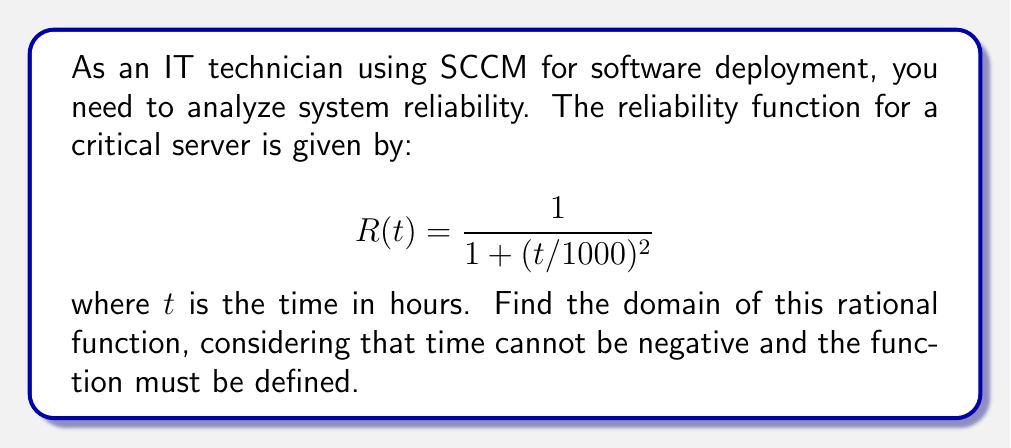Provide a solution to this math problem. To find the domain of the rational function, we need to follow these steps:

1) First, recall that for any rational function $\frac{p(x)}{q(x)}$, the domain includes all real numbers except those that make the denominator equal to zero.

2) In this case, our function is:
   $$R(t) = \frac{1}{1 + (t/1000)^2}$$

3) The denominator is $1 + (t/1000)^2$. We need to find values of $t$ that make this equal to zero:
   $$1 + (t/1000)^2 = 0$$

4) Solving this equation:
   $$(t/1000)^2 = -1$$

5) However, the square of a real number is always non-negative, so there are no real solutions to this equation.

6) This means the denominator is never zero for any real value of $t$.

7) Additionally, since $t$ represents time in hours, it cannot be negative in this context.

8) Therefore, the domain of this function is all non-negative real numbers.
Answer: $[0,\infty)$ 